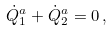Convert formula to latex. <formula><loc_0><loc_0><loc_500><loc_500>\dot { Q } ^ { a } _ { 1 } + \dot { Q } ^ { a } _ { 2 } = 0 \, ,</formula> 